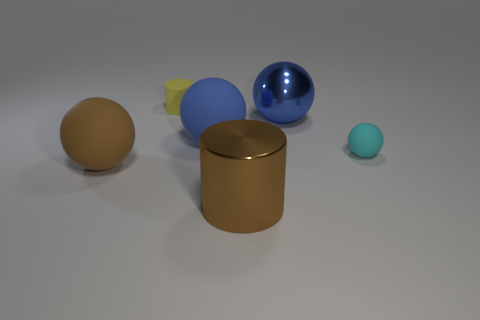Subtract 1 spheres. How many spheres are left? 3 Add 1 large purple metallic things. How many objects exist? 7 Subtract all spheres. How many objects are left? 2 Subtract 0 purple cubes. How many objects are left? 6 Subtract all cylinders. Subtract all large blue matte cylinders. How many objects are left? 4 Add 2 spheres. How many spheres are left? 6 Add 3 cyan spheres. How many cyan spheres exist? 4 